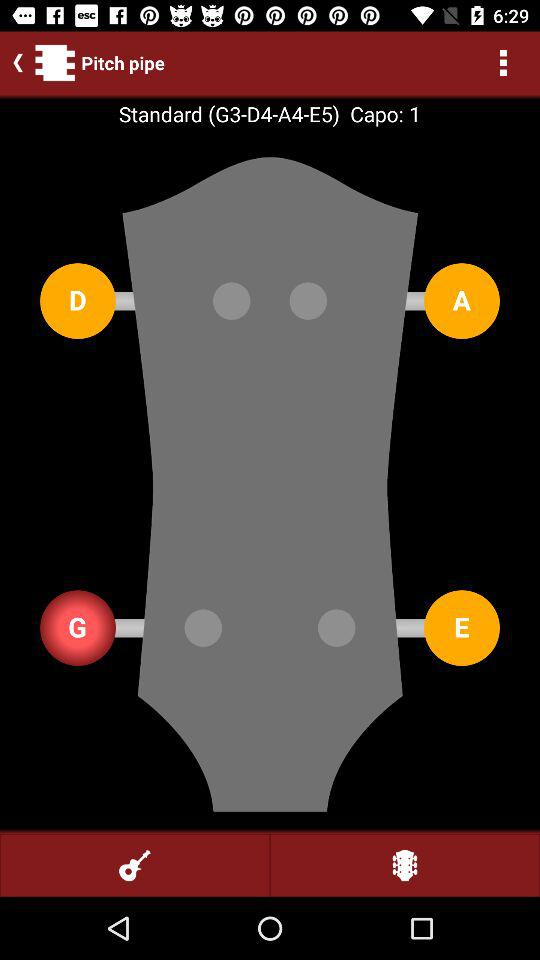How many capos are there? There is 1 capo. 